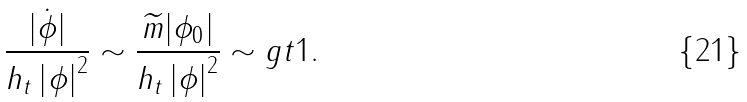Convert formula to latex. <formula><loc_0><loc_0><loc_500><loc_500>\frac { | \dot { \phi } | } { h _ { t } \left | \phi \right | ^ { 2 } } \sim \frac { \widetilde { m } | \phi _ { 0 } | } { h _ { t } \left | \phi \right | ^ { 2 } } \sim g t 1 .</formula> 